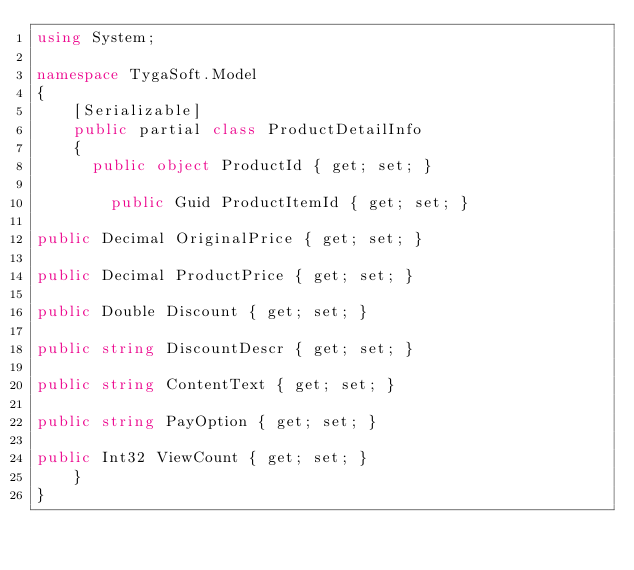<code> <loc_0><loc_0><loc_500><loc_500><_C#_>using System;

namespace TygaSoft.Model
{
    [Serializable]
    public partial class ProductDetailInfo
    {
	    public object ProductId { get; set; }

        public Guid ProductItemId { get; set; } 

public Decimal OriginalPrice { get; set; } 

public Decimal ProductPrice { get; set; } 

public Double Discount { get; set; } 

public string DiscountDescr { get; set; } 

public string ContentText { get; set; } 

public string PayOption { get; set; } 

public Int32 ViewCount { get; set; } 
    }
}
</code> 